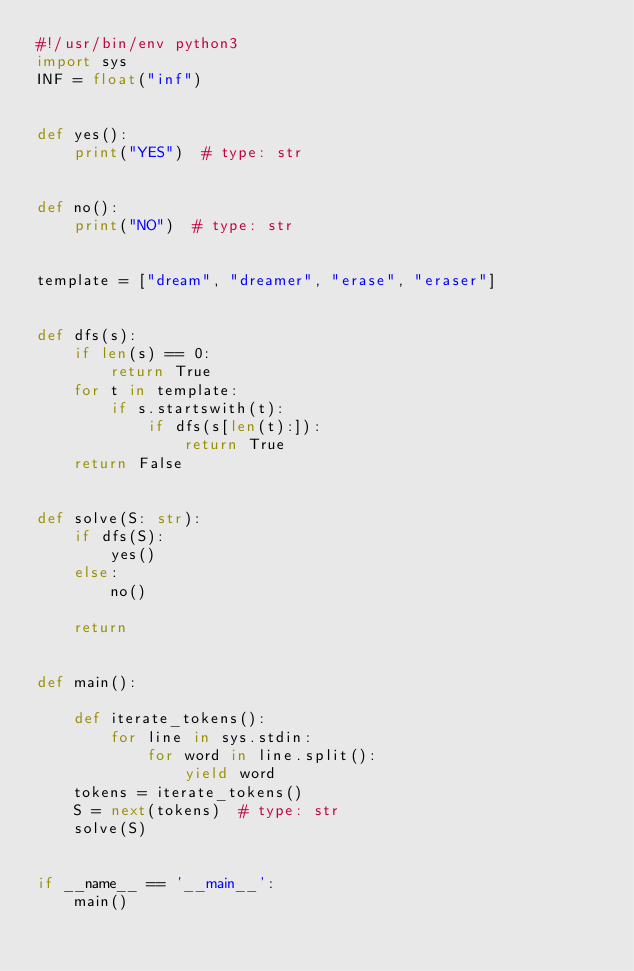<code> <loc_0><loc_0><loc_500><loc_500><_Python_>#!/usr/bin/env python3
import sys
INF = float("inf")


def yes():
    print("YES")  # type: str


def no():
    print("NO")  # type: str


template = ["dream", "dreamer", "erase", "eraser"]


def dfs(s):
    if len(s) == 0:
        return True
    for t in template:
        if s.startswith(t):
            if dfs(s[len(t):]):
                return True
    return False


def solve(S: str):
    if dfs(S):
        yes()
    else:
        no()

    return


def main():

    def iterate_tokens():
        for line in sys.stdin:
            for word in line.split():
                yield word
    tokens = iterate_tokens()
    S = next(tokens)  # type: str
    solve(S)


if __name__ == '__main__':
    main()
</code> 